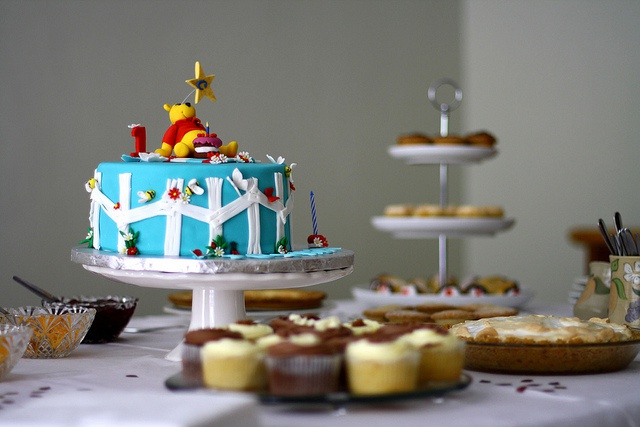Describe the objects in this image and their specific colors. I can see dining table in gray, darkgray, black, and maroon tones, cake in gray, white, lightblue, and teal tones, pizza in gray, tan, darkgray, olive, and maroon tones, cake in gray, maroon, and black tones, and cake in gray, tan, olive, and khaki tones in this image. 